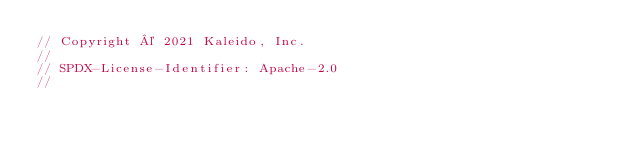<code> <loc_0><loc_0><loc_500><loc_500><_Go_>// Copyright © 2021 Kaleido, Inc.
//
// SPDX-License-Identifier: Apache-2.0
//</code> 